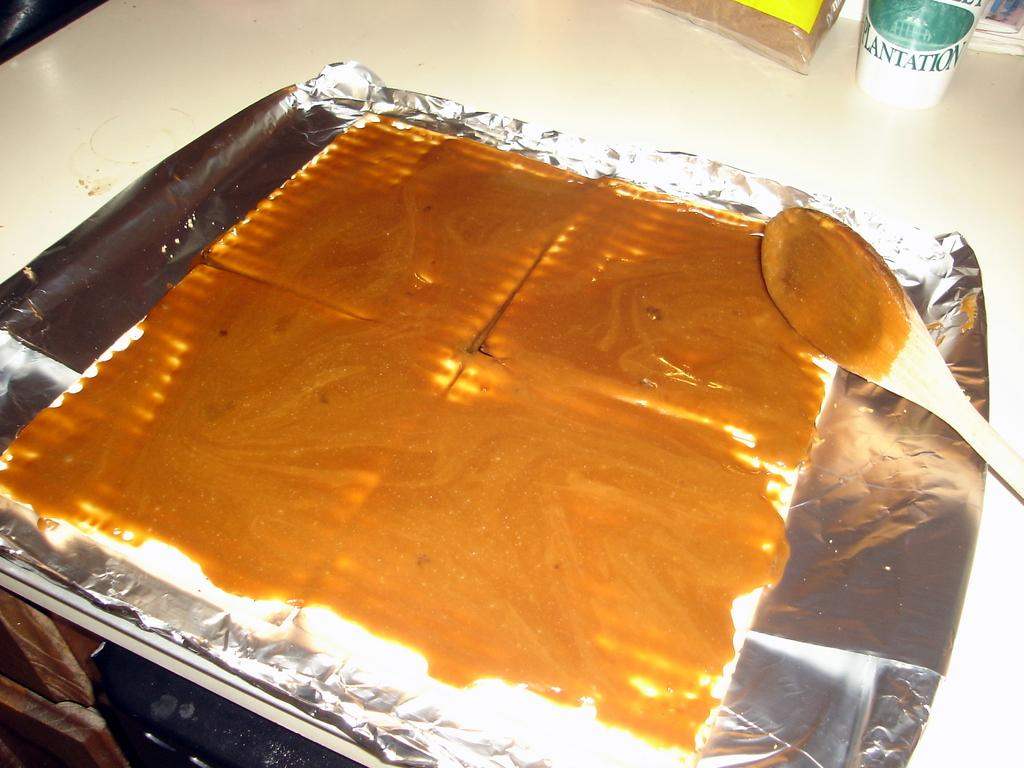<image>
Create a compact narrative representing the image presented. A cup that says PLANTATION is on a counter top behind a food item that has peanut butter spread out on it. 